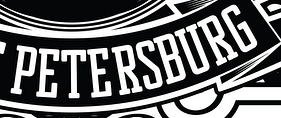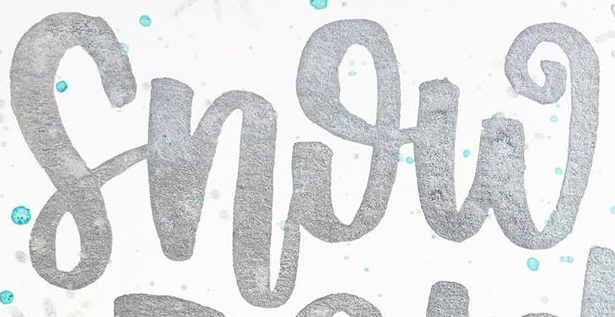What words can you see in these images in sequence, separated by a semicolon? PETERSBURG; Snow 